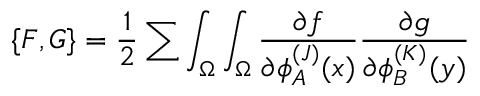Convert formula to latex. <formula><loc_0><loc_0><loc_500><loc_500>\{ F , G \} = { \frac { 1 } { 2 } } \sum \int _ { \Omega } \int _ { \Omega } { \frac { \partial f } { \partial \phi _ { A } ^ { ( J ) } ( x ) } } { \frac { \partial g } { \partial \phi _ { B } ^ { ( K ) } ( y ) } }</formula> 